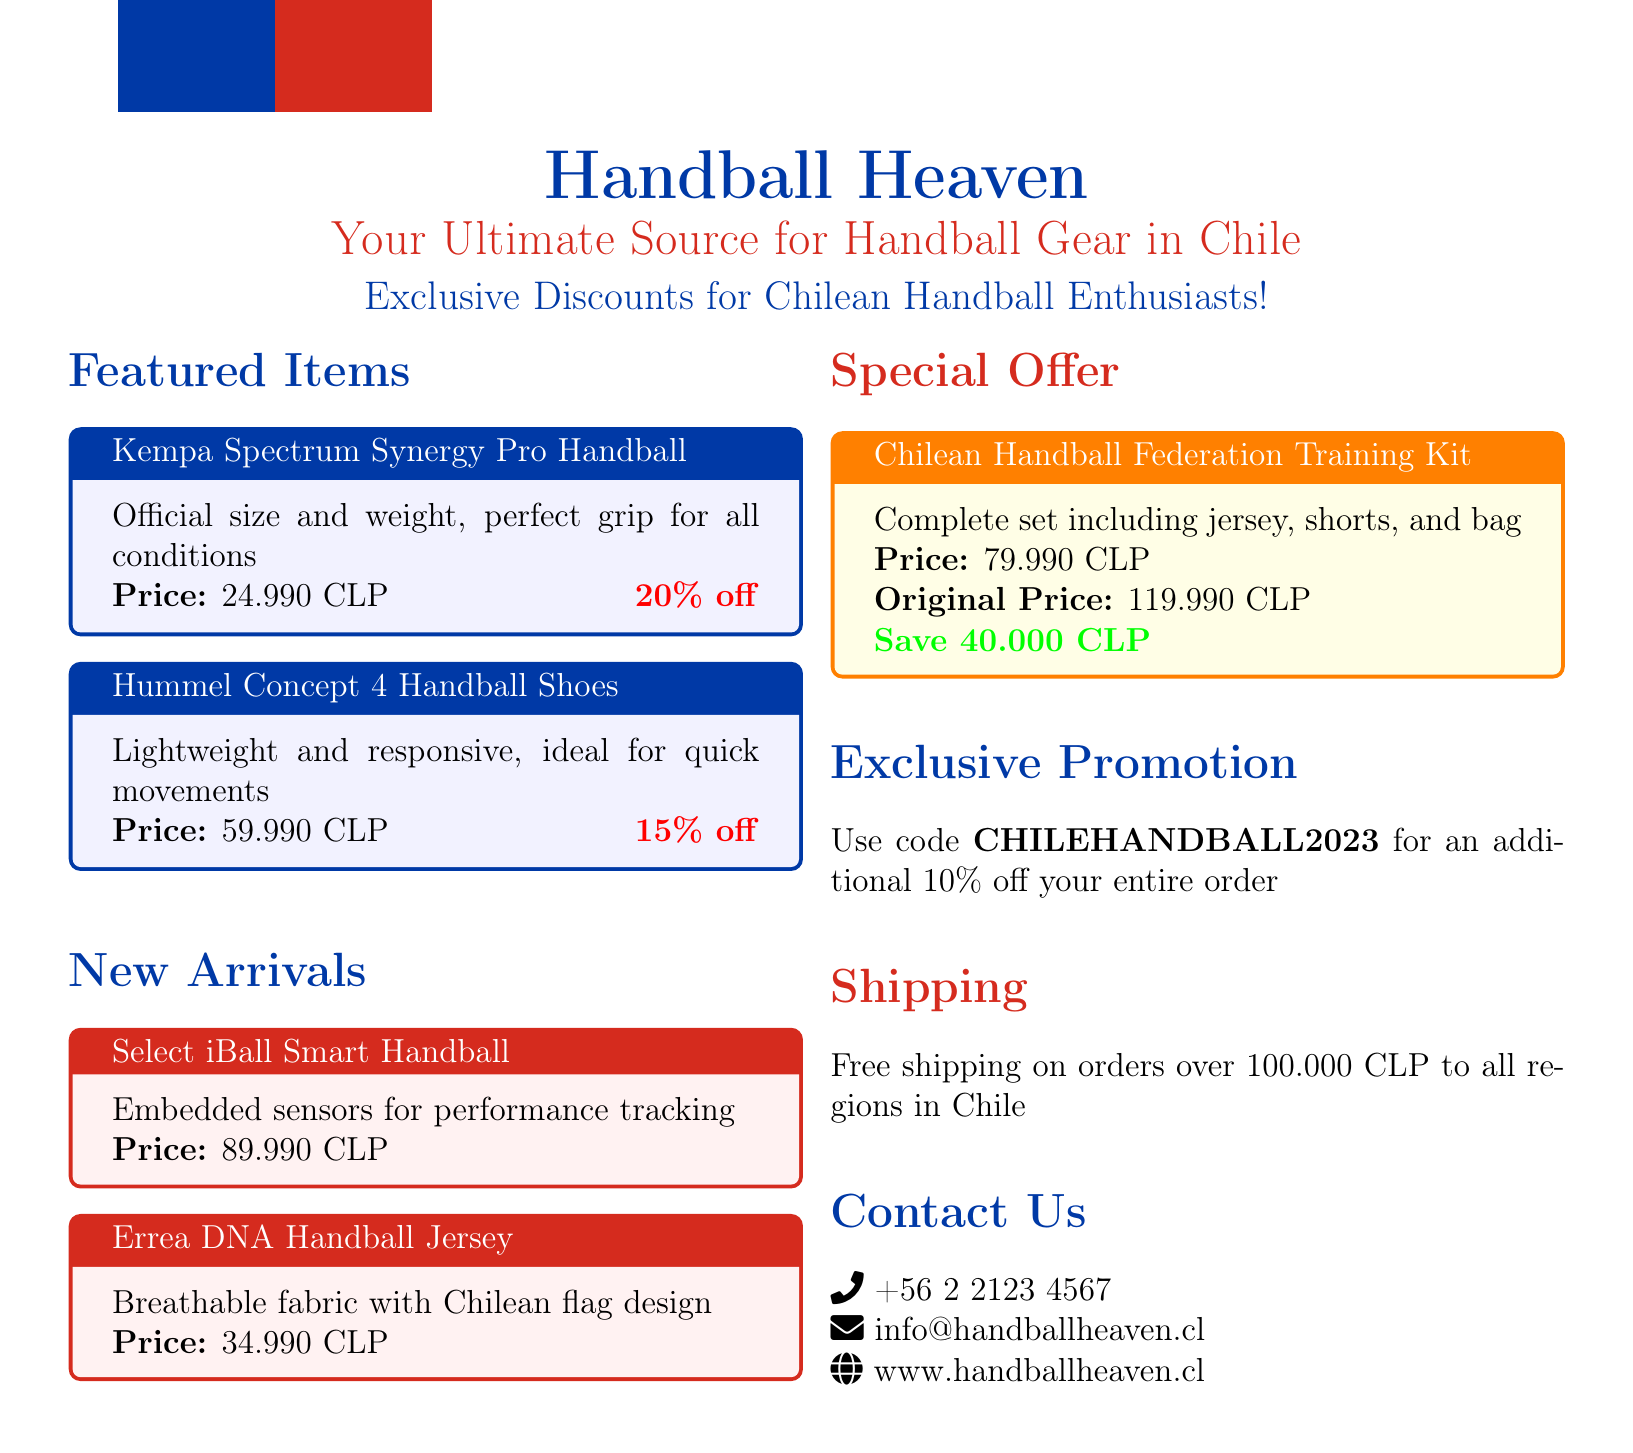What is the title of the catalog? The title of the catalog is prominently displayed at the top of the document.
Answer: Handball Heaven: Your Ultimate Source for Handball Gear in Chile What is the discount on the Kempa Spectrum Synergy Pro Handball? The discount percentage is clearly noted next to the product price.
Answer: 20% off What is the price of the Hummel Concept 4 Handball Shoes? The price is listed directly under the product description in the featured items section.
Answer: 59.990 CLP What is included in the Chilean Handball Federation Training Kit? The contents of the kit are explained in its special offer section.
Answer: Jersey, shorts, and bag What is the original price of the Training Kit? This price is provided for comparison under the special offer section.
Answer: 119.990 CLP What is the promotion code for additional discounts? The code is specific to this catalog and mentioned in the exclusive promotion section.
Answer: CHILEHANDBALL2023 What savings are offered with the Chilean Handball Federation Training Kit? The amount saved is highlighted in the special offer section to attract customers' attention.
Answer: Save 40.000 CLP What is the shipping offer for orders over a certain amount? Shipping terms are outlined at the end of the document.
Answer: Free shipping on orders over 100.000 CLP How can customers contact Handball Heaven? Contact information is provided in the document for customer inquiries.
Answer: +56 2 2123 4567, info@handballheaven.cl, www.handballheaven.cl 